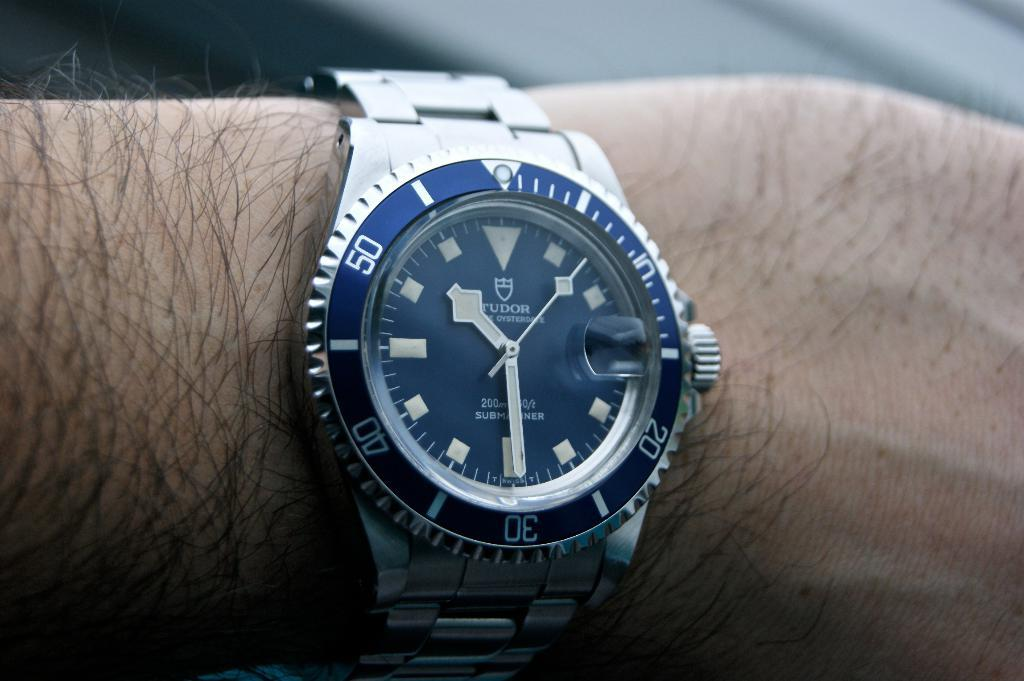<image>
Create a compact narrative representing the image presented. A Tudor watch on an arm has the time of 10:29. 